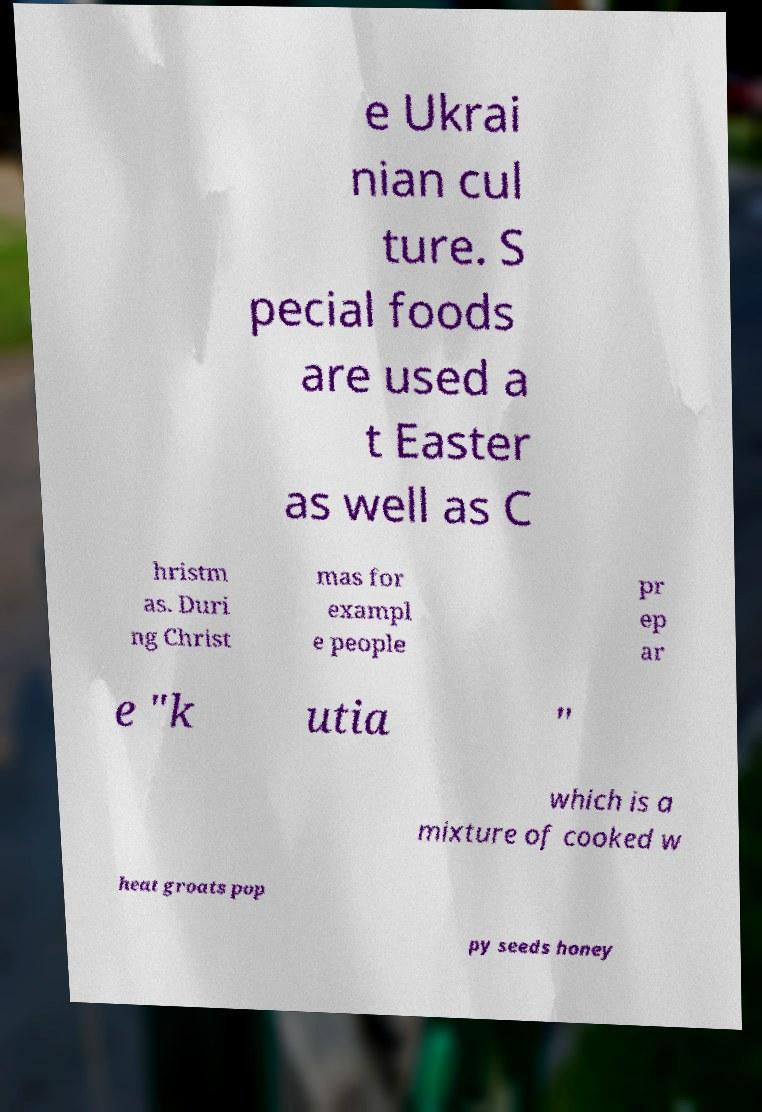There's text embedded in this image that I need extracted. Can you transcribe it verbatim? e Ukrai nian cul ture. S pecial foods are used a t Easter as well as C hristm as. Duri ng Christ mas for exampl e people pr ep ar e "k utia " which is a mixture of cooked w heat groats pop py seeds honey 